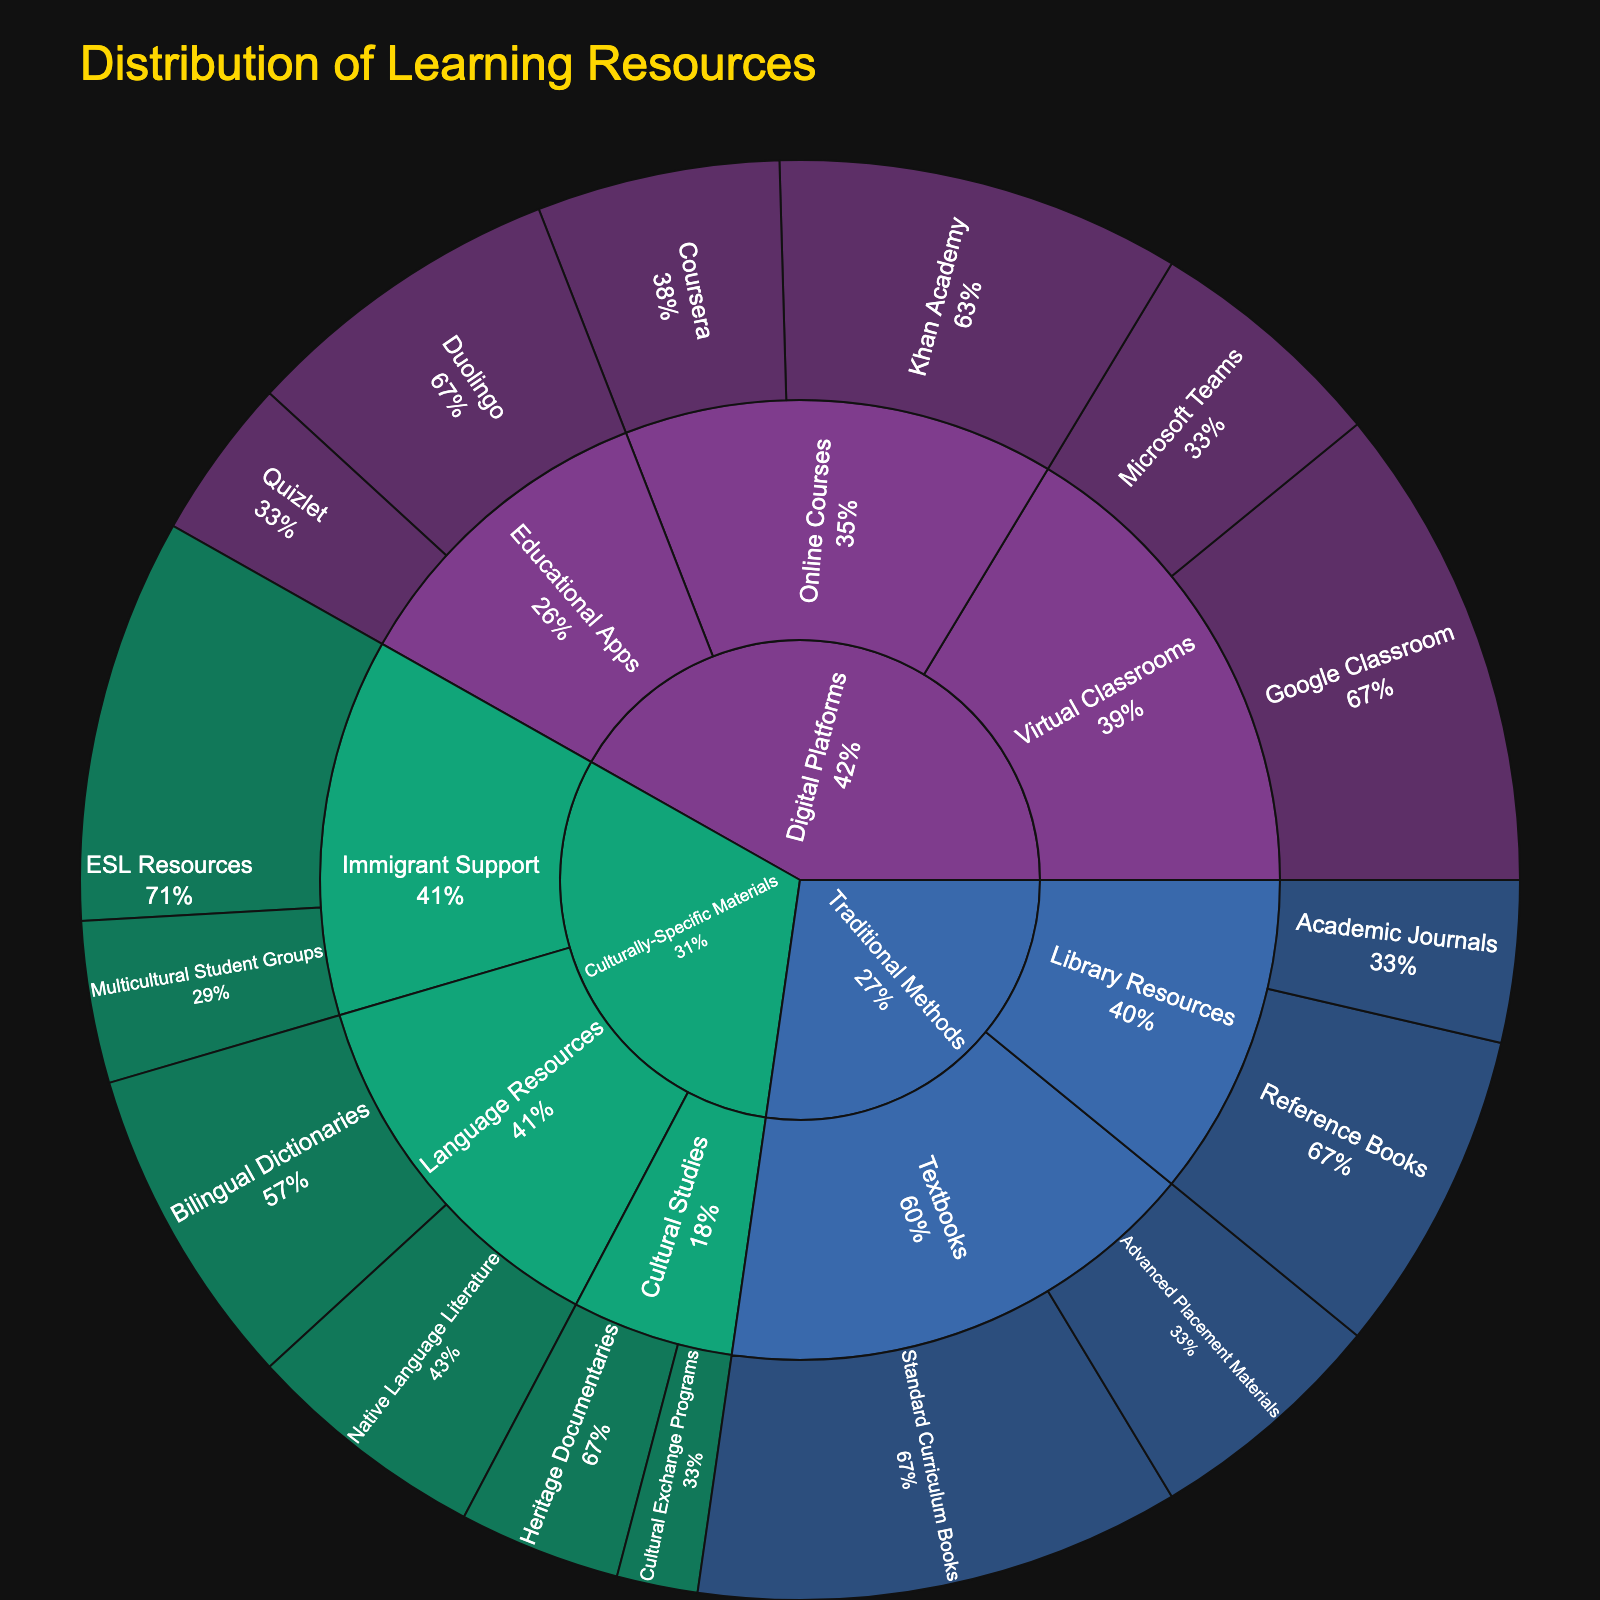What is the largest single resource category in the plot? The largest resource category is the one with the largest segment in the sunburst plot. By examining the plot, we see that the primary segment with the largest proportion is the "Digital Platforms" category, which is visually significant.
Answer: Digital Platforms What is the total value for Traditional Methods? To find the total value for Traditional Methods, sum up all the values associated with this category: 30 (Standard Curriculum Books) + 15 (Advanced Placement Materials) + 20 (Reference Books) + 10 (Academic Journals) = 75.
Answer: 75 Which subcategory within Digital Platforms has the highest value? By looking at the segments under the Digital Platforms category, we can see that "Virtual Classrooms" has higher values compared to "Online Courses" and "Educational Apps": 30 (Google Classroom) + 15 (Microsoft Teams) = 45, which is the highest.
Answer: Virtual Classrooms Compare the value of Standard Curriculum Books with the value of Google Classroom within their respective subcategories. Which one is higher? Standard Curriculum Books (30) belong to the Textbooks subcategory of Traditional Methods, and Google Classroom (30) is within Virtual Classrooms under Digital Platforms. Since both values are equal, neither is higher.
Answer: They are equal What percentage of Digital Platforms is contributed by Educational Apps? To get the percentage, sum the total values under Digital Platforms and find the portion attributed to Educational Apps. Digital Platforms has 25 (Khan Academy) + 15 (Coursera) + 20 (Duolingo) + 10 (Quizlet) + 30 (Google Classroom) + 15 (Microsoft Teams) = 115. Educational Apps have 20 (Duolingo) + 10 (Quizlet) = 30. So, (30 / 115) * 100 ≈ 26.1%.
Answer: 26.1% What is the total value for Culturally-Specific Materials? Sum up all the values associated with the Culturally-Specific Materials category: 20 (Bilingual Dictionaries) + 15 (Native Language Literature) + 10 (Heritage Documentaries) + 5 (Cultural Exchange Programs) + 25 (ESL Resources) + 10 (Multicultural Student Groups) = 85.
Answer: 85 What is the smallest single resource value in the plot? The smallest resource value can be found by examining the segments carefully; it is "Cultural Exchange Programs" with a value of 5.
Answer: 5 How does the value of ESL Resources compare to the value of Coursera? ESL Resources (25) belong to the Immigrant Support subcategory under Culturally-Specific Materials, and Coursera (15) is under Online Courses in Digital Platforms. ESL Resources has a higher value than Coursera.
Answer: ESL Resources > Coursera 